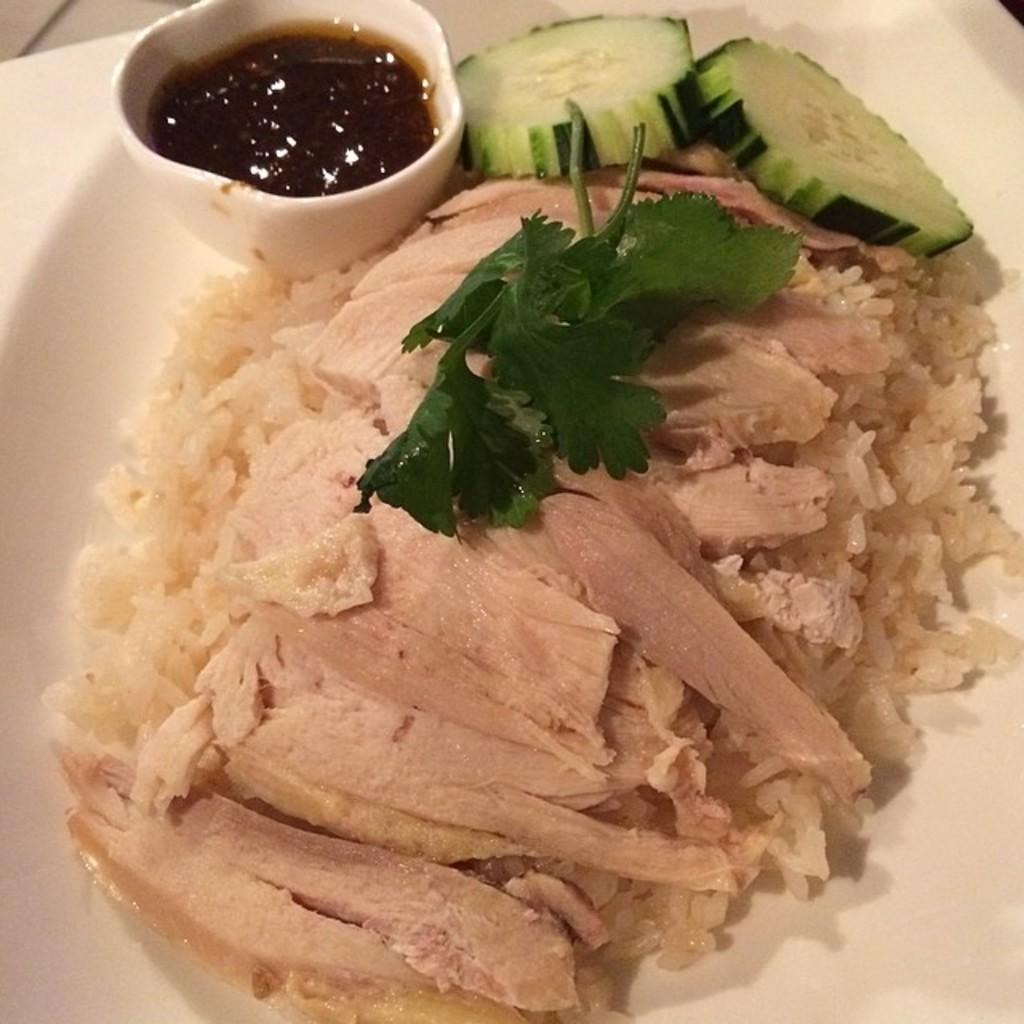What type of food can be seen in the image? There is food in the image, but the specific type is not mentioned. What is the bowl in the image used for? The bowl in the image contains sauce. What is the color of the plate that the bowl and food are placed on? The plate is white. Can you hear the thunder in the image? There is no mention of thunder or any sound in the image, so it cannot be heard. What is the sister doing in the image? There is no mention of a sister or any person in the image. 